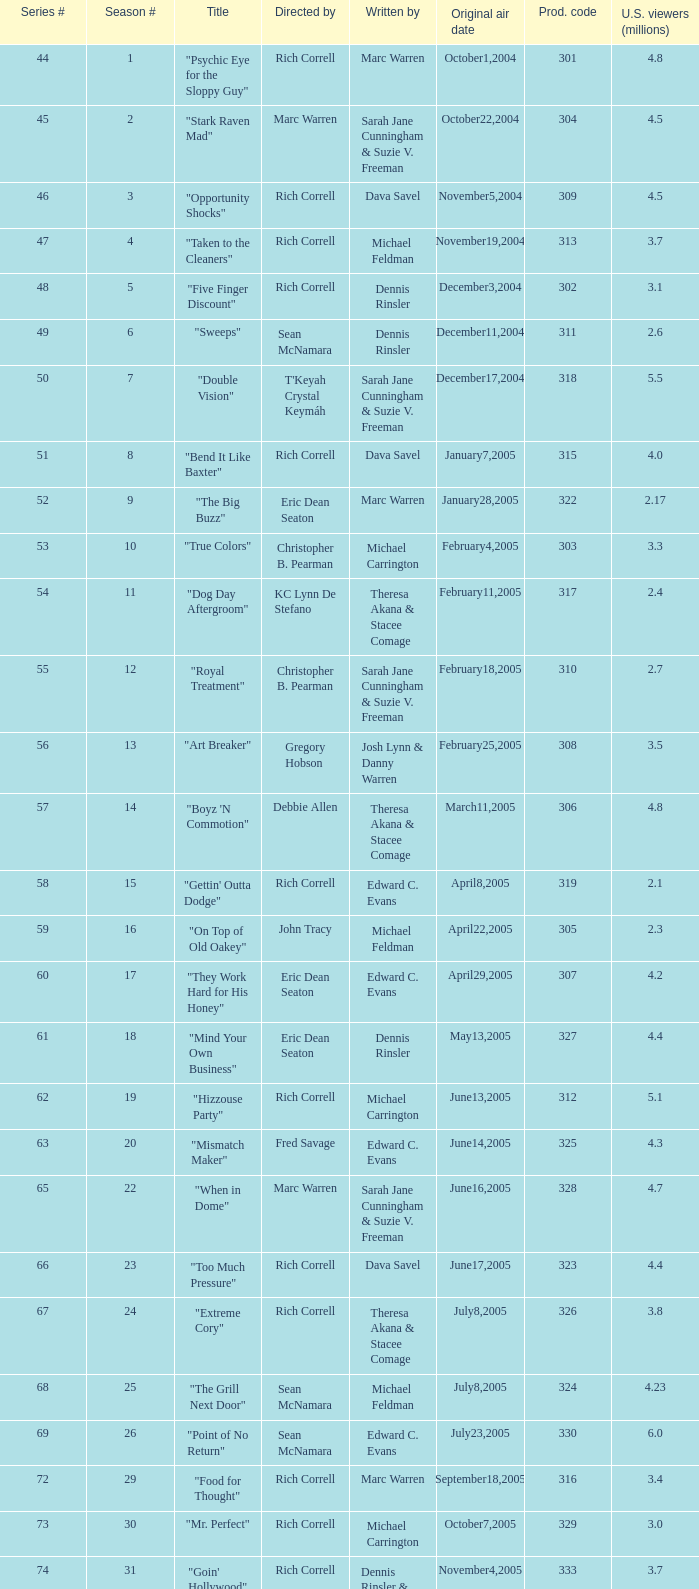What number episode in the season had a production code of 334? 32.0. 